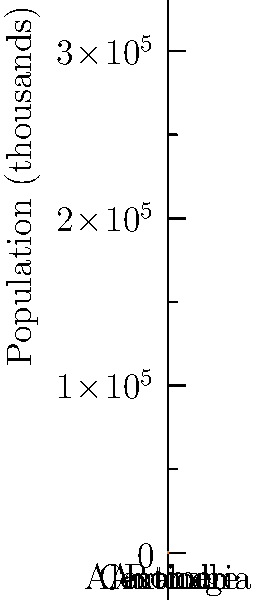Based on the chart comparing populations of ancient cities using scaled human figures, which city had a population approximately twice that of Antioch? To answer this question, we need to follow these steps:

1. Identify Antioch's population:
   - Count the number of human figures for Antioch (green column)
   - There are 4 figures for Antioch
   - Each figure represents 50,000 people
   - So, Antioch's population is $4 \times 50,000 = 200,000$

2. Find a city with twice Antioch's population:
   - We're looking for a city with $200,000 \times 2 = 400,000$ people
   - This would be represented by 8 human figures

3. Examine the other cities:
   - Rome (red): 10 figures, representing 500,000 people
   - Alexandria (blue): 6 figures, representing 300,000 people
   - Carthage (orange): 2 figures, representing 100,000 people

4. Compare with Antioch's population:
   - Rome: More than twice Antioch's population
   - Alexandria: 1.5 times Antioch's population
   - Carthage: Half of Antioch's population

5. Conclusion:
   - Alexandria is the closest to twice Antioch's population, but it's not exactly twice
   - Rome is more than twice, while Carthage is less than Antioch's population

Therefore, no city has exactly twice the population of Antioch, but Rome is the only city with more than twice Antioch's population.
Answer: Rome 